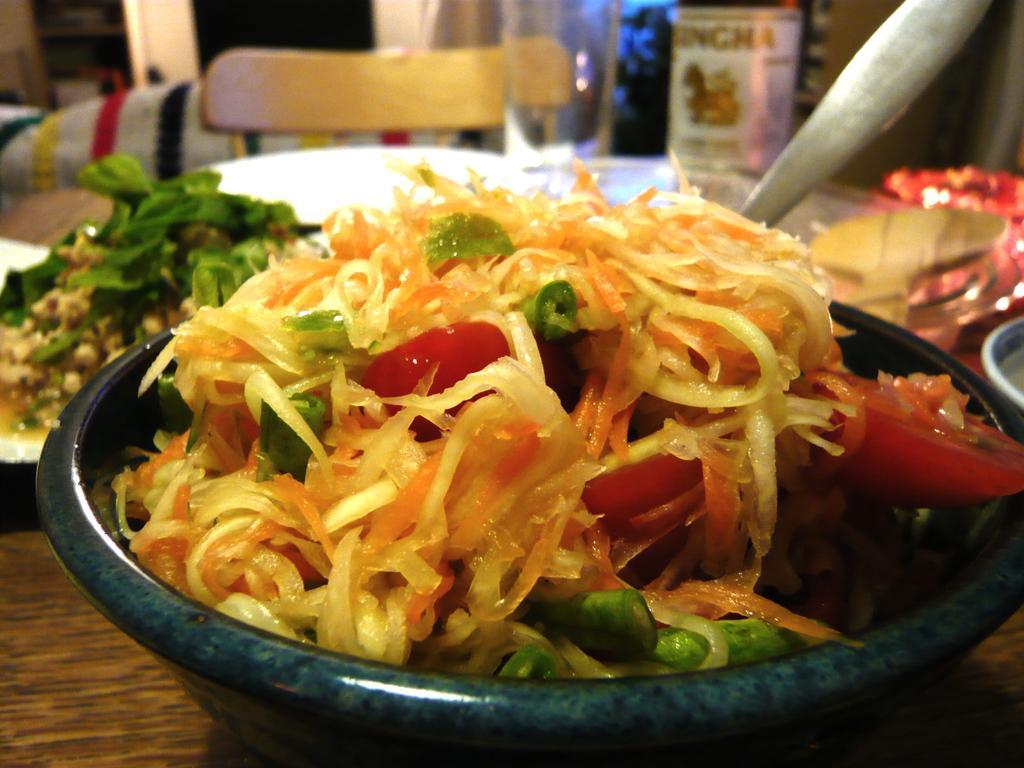Please provide a concise description of this image. In the center of the image there is a table and we can see bowls, plates, spoons, spatula and food placed on the table. In the background there is a chair and a wall. 